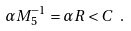<formula> <loc_0><loc_0><loc_500><loc_500>\alpha M _ { 5 } ^ { - 1 } = \alpha R < C \ .</formula> 